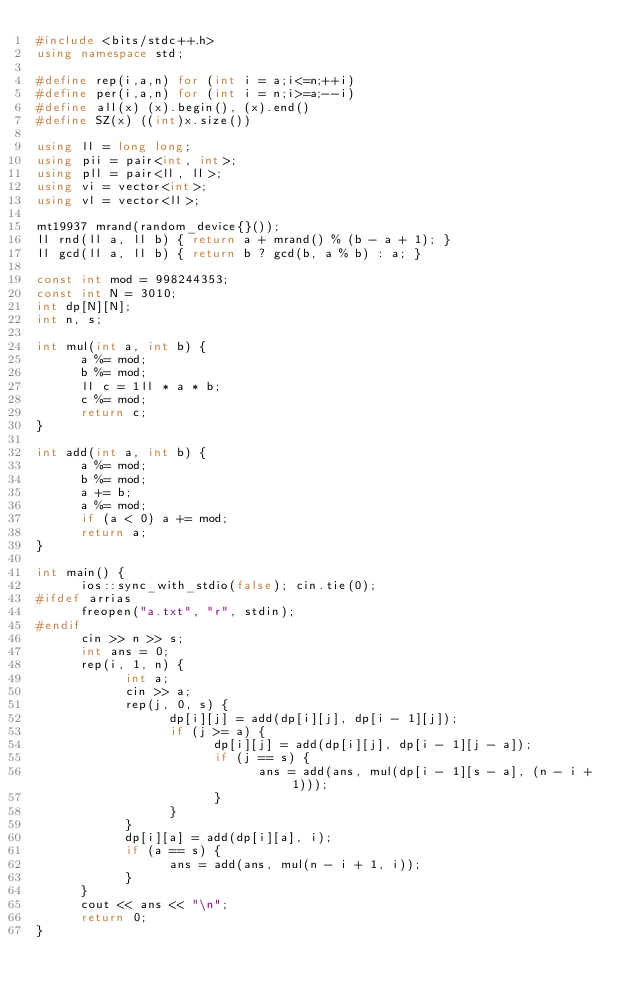<code> <loc_0><loc_0><loc_500><loc_500><_C++_>#include <bits/stdc++.h>
using namespace std;

#define rep(i,a,n) for (int i = a;i<=n;++i)
#define per(i,a,n) for (int i = n;i>=a;--i)
#define all(x) (x).begin(), (x).end()     
#define SZ(x) ((int)x.size())

using ll = long long;
using pii = pair<int, int>;
using pll = pair<ll, ll>;
using vi = vector<int>;
using vl = vector<ll>;

mt19937 mrand(random_device{}());
ll rnd(ll a, ll b) { return a + mrand() % (b - a + 1); }
ll gcd(ll a, ll b) { return b ? gcd(b, a % b) : a; }

const int mod = 998244353;
const int N = 3010;
int dp[N][N];
int n, s;

int mul(int a, int b) {
      a %= mod;
      b %= mod;
      ll c = 1ll * a * b;
      c %= mod;
      return c;
}

int add(int a, int b) {
      a %= mod;
      b %= mod;
      a += b;
      a %= mod;
      if (a < 0) a += mod;
      return a;
}

int main() {
      ios::sync_with_stdio(false); cin.tie(0);
#ifdef arrias
      freopen("a.txt", "r", stdin);
#endif
      cin >> n >> s;
      int ans = 0;
      rep(i, 1, n) {
            int a;
            cin >> a;
            rep(j, 0, s) {
                  dp[i][j] = add(dp[i][j], dp[i - 1][j]);
                  if (j >= a) {
                        dp[i][j] = add(dp[i][j], dp[i - 1][j - a]);
                        if (j == s) {
                              ans = add(ans, mul(dp[i - 1][s - a], (n - i + 1)));
                        }
                  }     
            }
            dp[i][a] = add(dp[i][a], i);
            if (a == s) {
                  ans = add(ans, mul(n - i + 1, i));
            }
      }
      cout << ans << "\n";
      return 0;
}</code> 